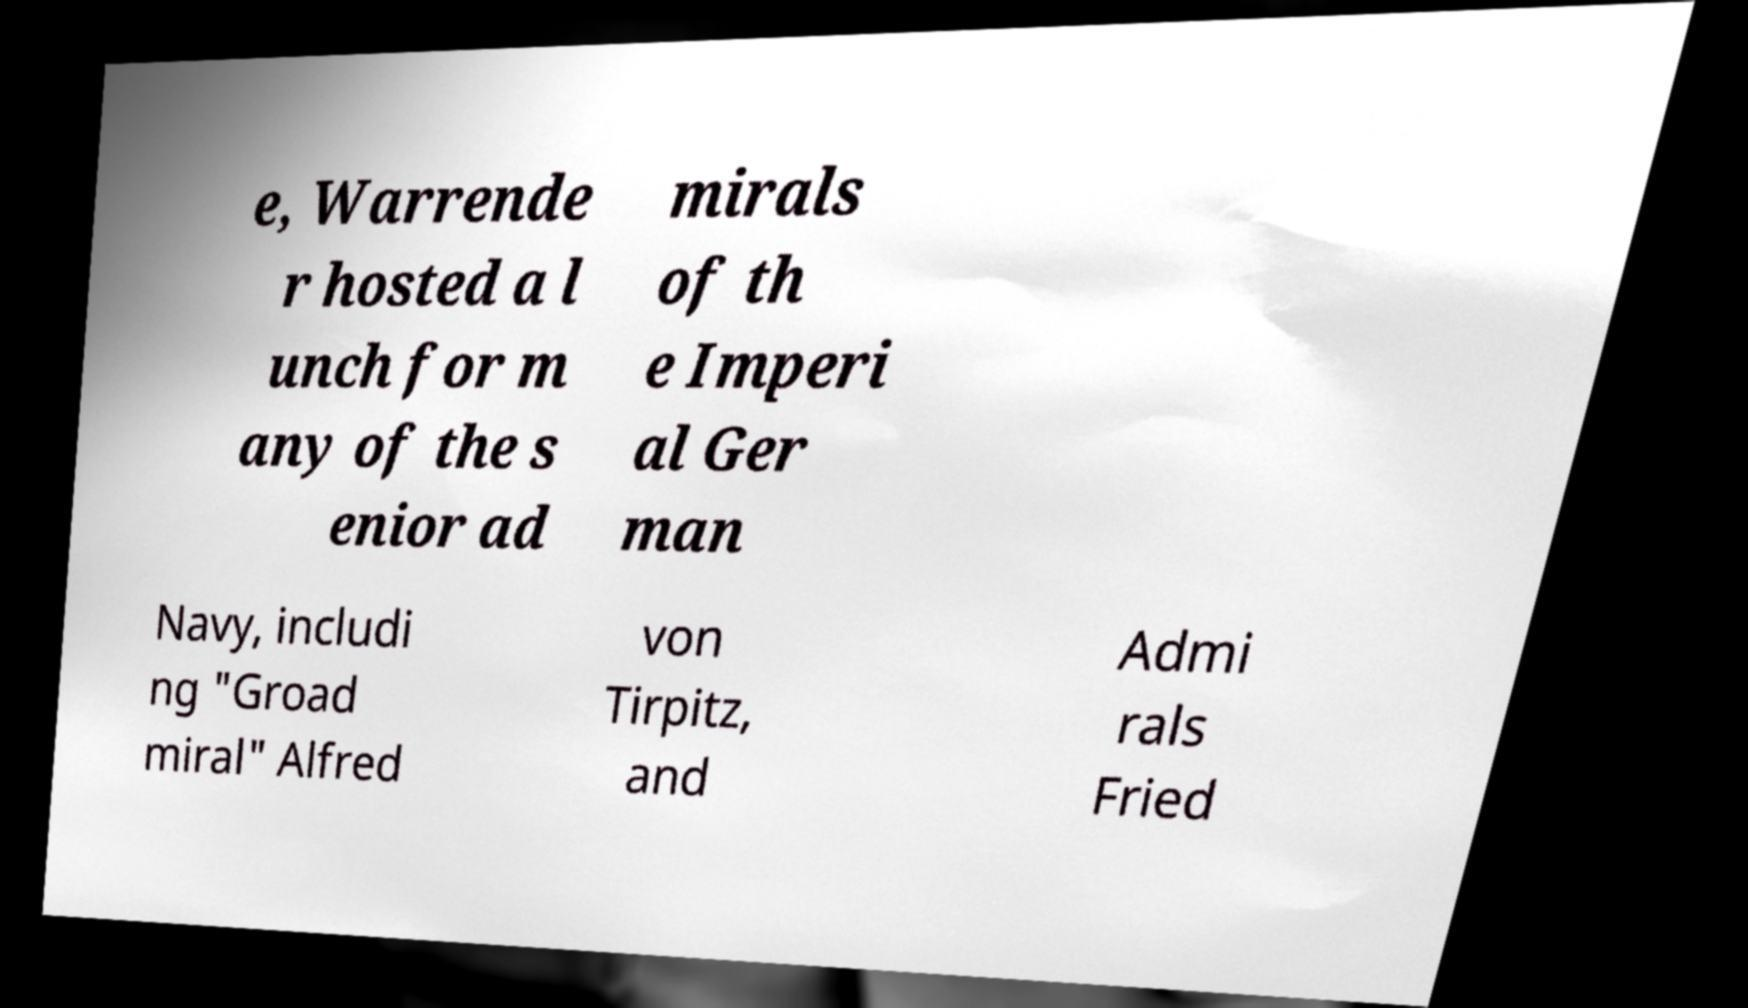Can you accurately transcribe the text from the provided image for me? e, Warrende r hosted a l unch for m any of the s enior ad mirals of th e Imperi al Ger man Navy, includi ng "Groad miral" Alfred von Tirpitz, and Admi rals Fried 